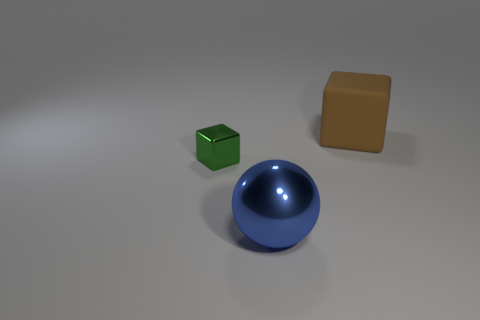Is there any other thing that is the same material as the big brown cube?
Your answer should be compact. No. What number of other things are there of the same size as the green cube?
Ensure brevity in your answer.  0. Are there any brown balls that have the same size as the brown cube?
Keep it short and to the point. No. There is a big thing on the left side of the brown matte block; is it the same color as the small shiny object?
Your answer should be very brief. No. What number of things are either big blue spheres or brown things?
Offer a terse response. 2. Is the size of the block in front of the brown matte object the same as the large brown block?
Give a very brief answer. No. There is a object that is behind the big blue metal thing and in front of the brown cube; what is its size?
Offer a very short reply. Small. What number of other things are there of the same shape as the large brown matte object?
Keep it short and to the point. 1. How many other things are there of the same material as the big brown thing?
Give a very brief answer. 0. There is a brown matte object that is the same shape as the small green object; what size is it?
Give a very brief answer. Large. 